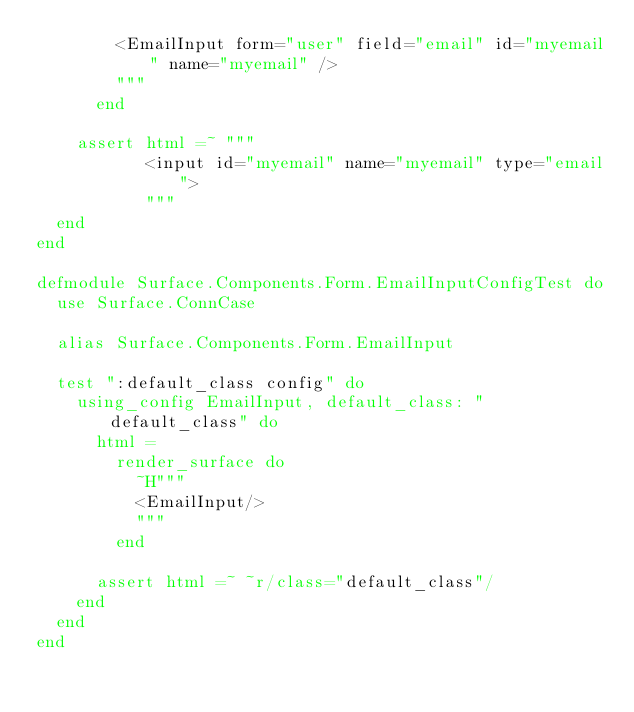<code> <loc_0><loc_0><loc_500><loc_500><_Elixir_>        <EmailInput form="user" field="email" id="myemail" name="myemail" />
        """
      end

    assert html =~ """
           <input id="myemail" name="myemail" type="email">
           """
  end
end

defmodule Surface.Components.Form.EmailInputConfigTest do
  use Surface.ConnCase

  alias Surface.Components.Form.EmailInput

  test ":default_class config" do
    using_config EmailInput, default_class: "default_class" do
      html =
        render_surface do
          ~H"""
          <EmailInput/>
          """
        end

      assert html =~ ~r/class="default_class"/
    end
  end
end
</code> 